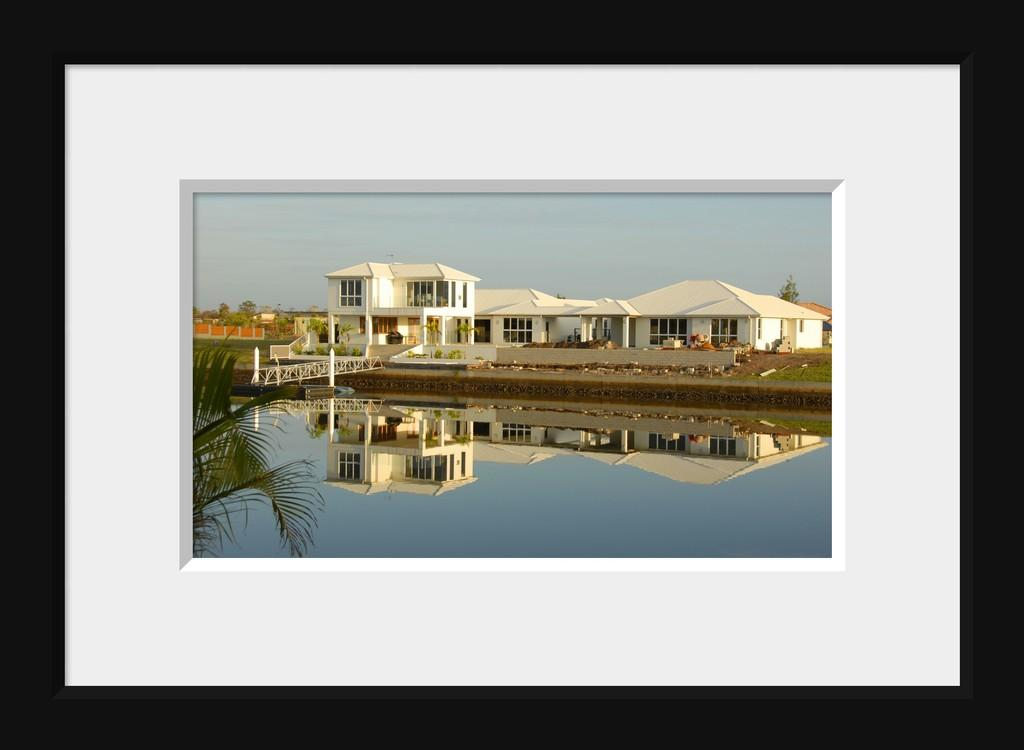What type of object is the image contained within? The image is in a photo frame. What is depicted in the image within the frame? There is an image of a house in the frame. What can be seen behind the house in the image? There are trees behind the house in the image. What is visible behind the trees in the image? The sky is visible behind the house and trees in the image. What is located in front of the house in the image? There is water in front of the house in the image. How many legs does the house have in the image? Houses do not have legs; they are stationary structures. The image shows a house with a foundation, but it does not have legs. 